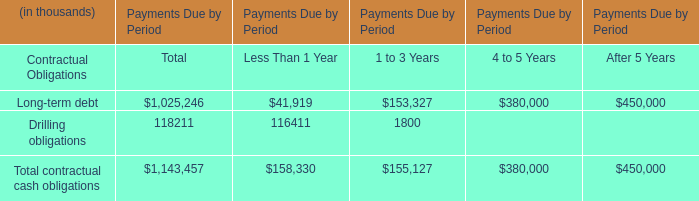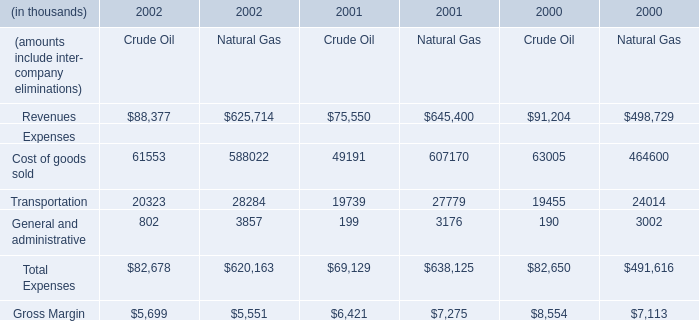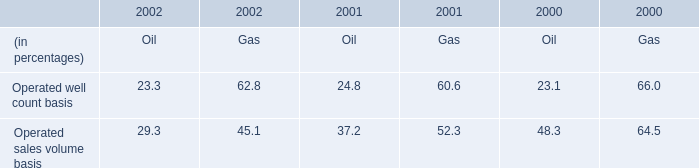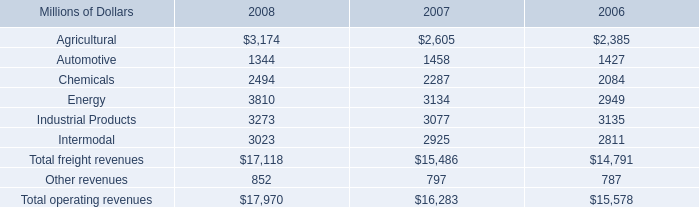in 2006 what was the percent of other revenues re-classed from freight 
Computations: (71 / 787)
Answer: 0.09022. 